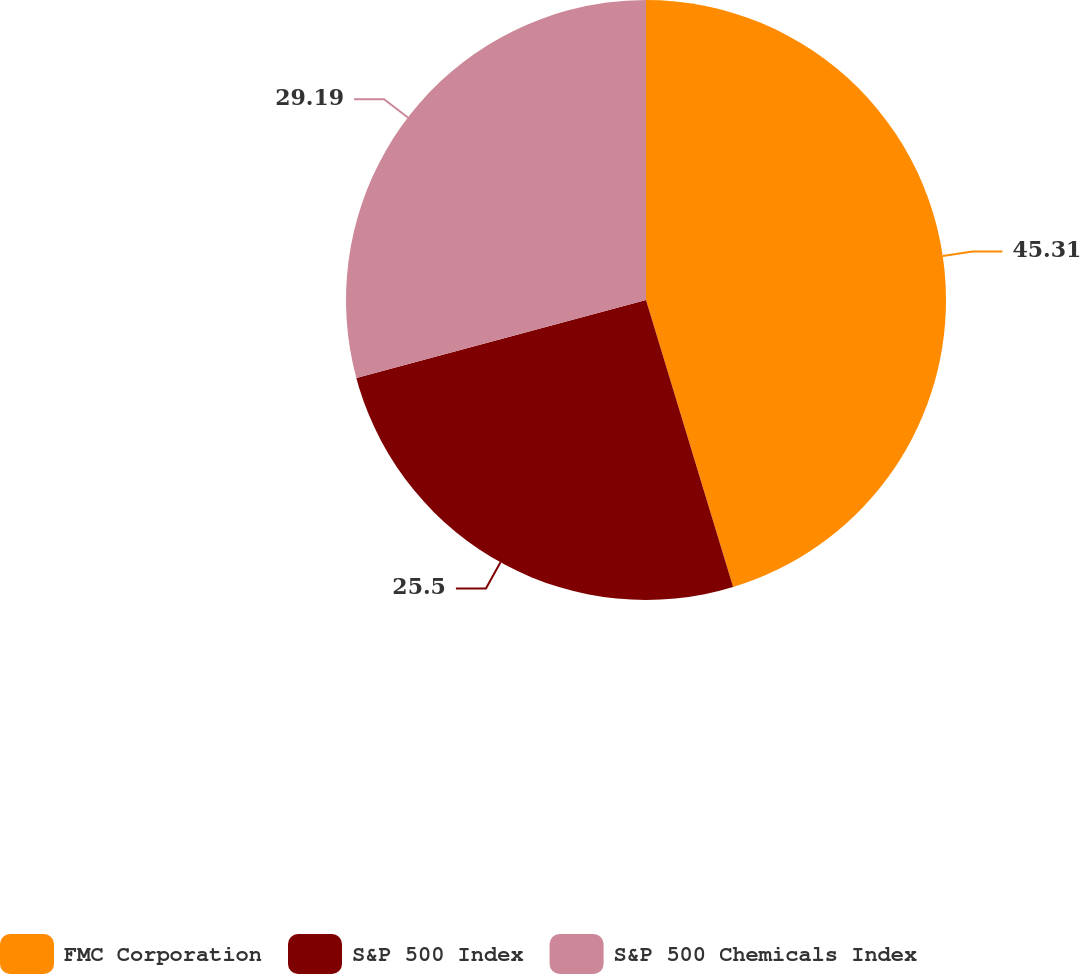Convert chart. <chart><loc_0><loc_0><loc_500><loc_500><pie_chart><fcel>FMC Corporation<fcel>S&P 500 Index<fcel>S&P 500 Chemicals Index<nl><fcel>45.31%<fcel>25.5%<fcel>29.19%<nl></chart> 